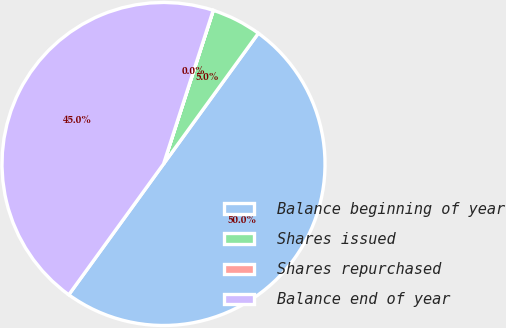Convert chart to OTSL. <chart><loc_0><loc_0><loc_500><loc_500><pie_chart><fcel>Balance beginning of year<fcel>Shares issued<fcel>Shares repurchased<fcel>Balance end of year<nl><fcel>49.99%<fcel>5.0%<fcel>0.01%<fcel>45.0%<nl></chart> 